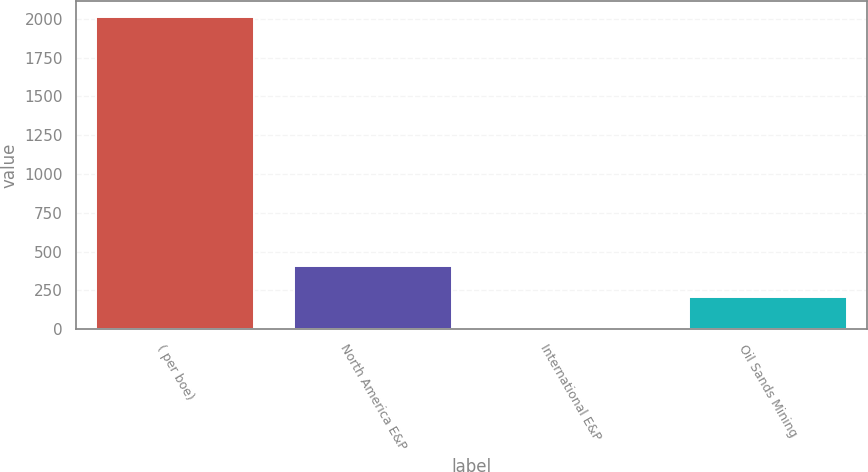Convert chart to OTSL. <chart><loc_0><loc_0><loc_500><loc_500><bar_chart><fcel>( per boe)<fcel>North America E&P<fcel>International E&P<fcel>Oil Sands Mining<nl><fcel>2013<fcel>407.28<fcel>5.86<fcel>206.57<nl></chart> 